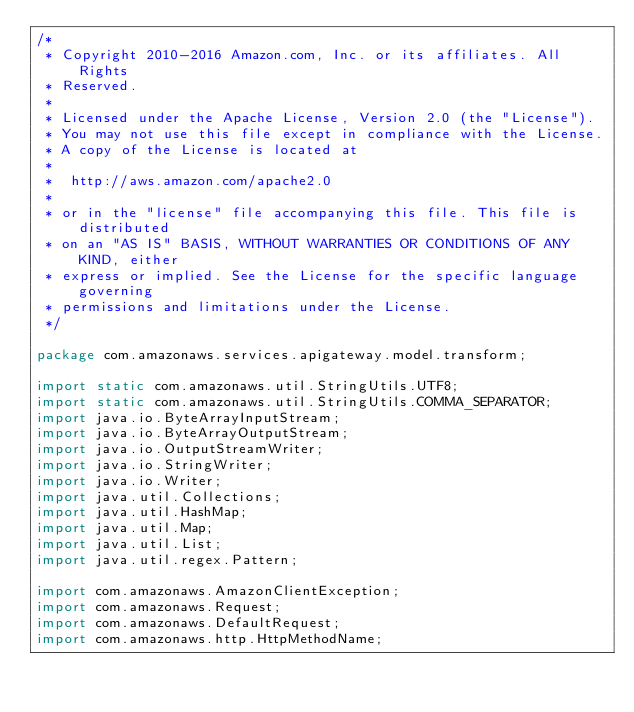Convert code to text. <code><loc_0><loc_0><loc_500><loc_500><_Java_>/*
 * Copyright 2010-2016 Amazon.com, Inc. or its affiliates. All Rights
 * Reserved.
 *
 * Licensed under the Apache License, Version 2.0 (the "License").
 * You may not use this file except in compliance with the License.
 * A copy of the License is located at
 *
 *  http://aws.amazon.com/apache2.0
 *
 * or in the "license" file accompanying this file. This file is distributed
 * on an "AS IS" BASIS, WITHOUT WARRANTIES OR CONDITIONS OF ANY KIND, either
 * express or implied. See the License for the specific language governing
 * permissions and limitations under the License.
 */

package com.amazonaws.services.apigateway.model.transform;

import static com.amazonaws.util.StringUtils.UTF8;
import static com.amazonaws.util.StringUtils.COMMA_SEPARATOR;
import java.io.ByteArrayInputStream;
import java.io.ByteArrayOutputStream;
import java.io.OutputStreamWriter;
import java.io.StringWriter;
import java.io.Writer;
import java.util.Collections;
import java.util.HashMap;
import java.util.Map;
import java.util.List;
import java.util.regex.Pattern;

import com.amazonaws.AmazonClientException;
import com.amazonaws.Request;
import com.amazonaws.DefaultRequest;
import com.amazonaws.http.HttpMethodName;</code> 